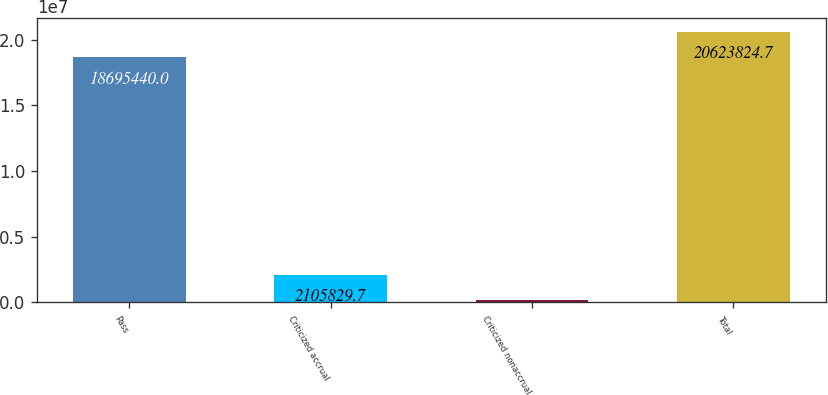Convert chart. <chart><loc_0><loc_0><loc_500><loc_500><bar_chart><fcel>Pass<fcel>Criticized accrual<fcel>Criticized nonaccrual<fcel>Total<nl><fcel>1.86954e+07<fcel>2.10583e+06<fcel>177445<fcel>2.06238e+07<nl></chart> 